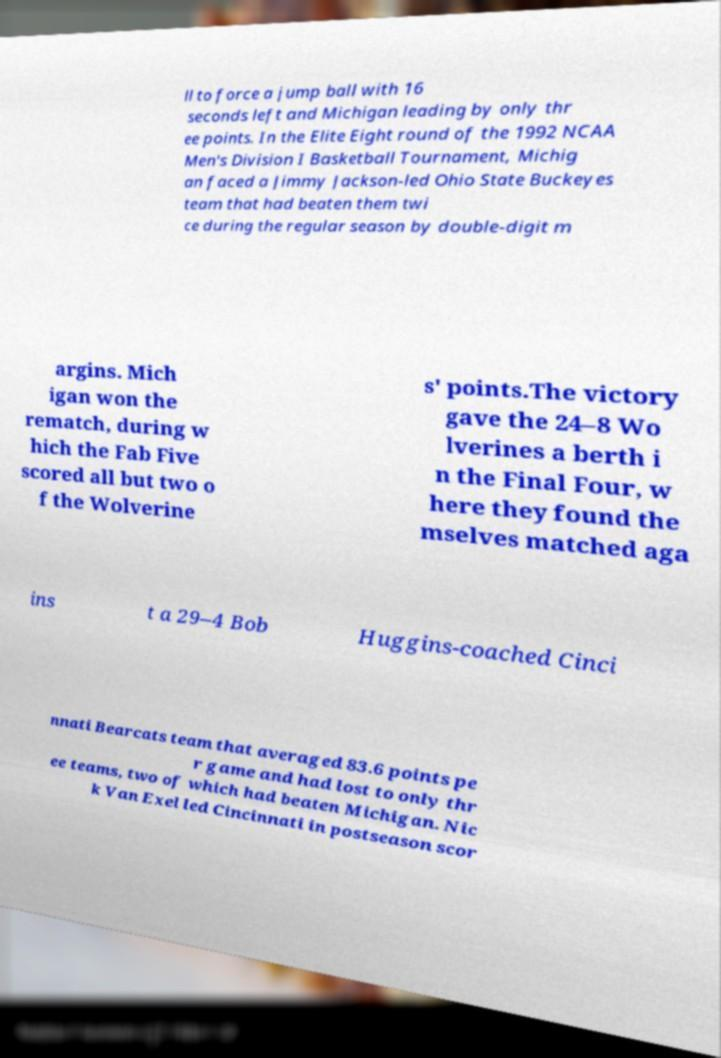Could you extract and type out the text from this image? ll to force a jump ball with 16 seconds left and Michigan leading by only thr ee points. In the Elite Eight round of the 1992 NCAA Men's Division I Basketball Tournament, Michig an faced a Jimmy Jackson-led Ohio State Buckeyes team that had beaten them twi ce during the regular season by double-digit m argins. Mich igan won the rematch, during w hich the Fab Five scored all but two o f the Wolverine s' points.The victory gave the 24–8 Wo lverines a berth i n the Final Four, w here they found the mselves matched aga ins t a 29–4 Bob Huggins-coached Cinci nnati Bearcats team that averaged 83.6 points pe r game and had lost to only thr ee teams, two of which had beaten Michigan. Nic k Van Exel led Cincinnati in postseason scor 